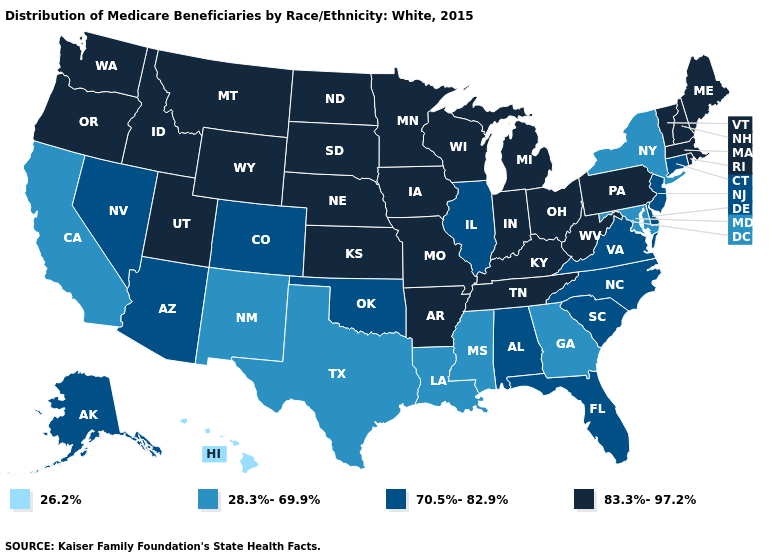Does the map have missing data?
Keep it brief. No. Name the states that have a value in the range 28.3%-69.9%?
Write a very short answer. California, Georgia, Louisiana, Maryland, Mississippi, New Mexico, New York, Texas. Which states have the lowest value in the Northeast?
Quick response, please. New York. Does the first symbol in the legend represent the smallest category?
Write a very short answer. Yes. Which states have the highest value in the USA?
Keep it brief. Arkansas, Idaho, Indiana, Iowa, Kansas, Kentucky, Maine, Massachusetts, Michigan, Minnesota, Missouri, Montana, Nebraska, New Hampshire, North Dakota, Ohio, Oregon, Pennsylvania, Rhode Island, South Dakota, Tennessee, Utah, Vermont, Washington, West Virginia, Wisconsin, Wyoming. What is the value of Washington?
Concise answer only. 83.3%-97.2%. Name the states that have a value in the range 83.3%-97.2%?
Concise answer only. Arkansas, Idaho, Indiana, Iowa, Kansas, Kentucky, Maine, Massachusetts, Michigan, Minnesota, Missouri, Montana, Nebraska, New Hampshire, North Dakota, Ohio, Oregon, Pennsylvania, Rhode Island, South Dakota, Tennessee, Utah, Vermont, Washington, West Virginia, Wisconsin, Wyoming. What is the value of Connecticut?
Give a very brief answer. 70.5%-82.9%. Does Maine have the highest value in the USA?
Concise answer only. Yes. Does the map have missing data?
Answer briefly. No. Does Ohio have the highest value in the MidWest?
Keep it brief. Yes. Does the map have missing data?
Be succinct. No. What is the lowest value in states that border New Hampshire?
Give a very brief answer. 83.3%-97.2%. What is the lowest value in the MidWest?
Quick response, please. 70.5%-82.9%. Name the states that have a value in the range 28.3%-69.9%?
Be succinct. California, Georgia, Louisiana, Maryland, Mississippi, New Mexico, New York, Texas. 